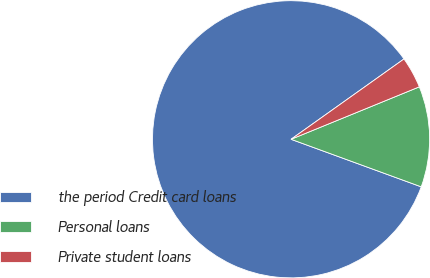Convert chart. <chart><loc_0><loc_0><loc_500><loc_500><pie_chart><fcel>the period Credit card loans<fcel>Personal loans<fcel>Private student loans<nl><fcel>84.58%<fcel>11.75%<fcel>3.66%<nl></chart> 